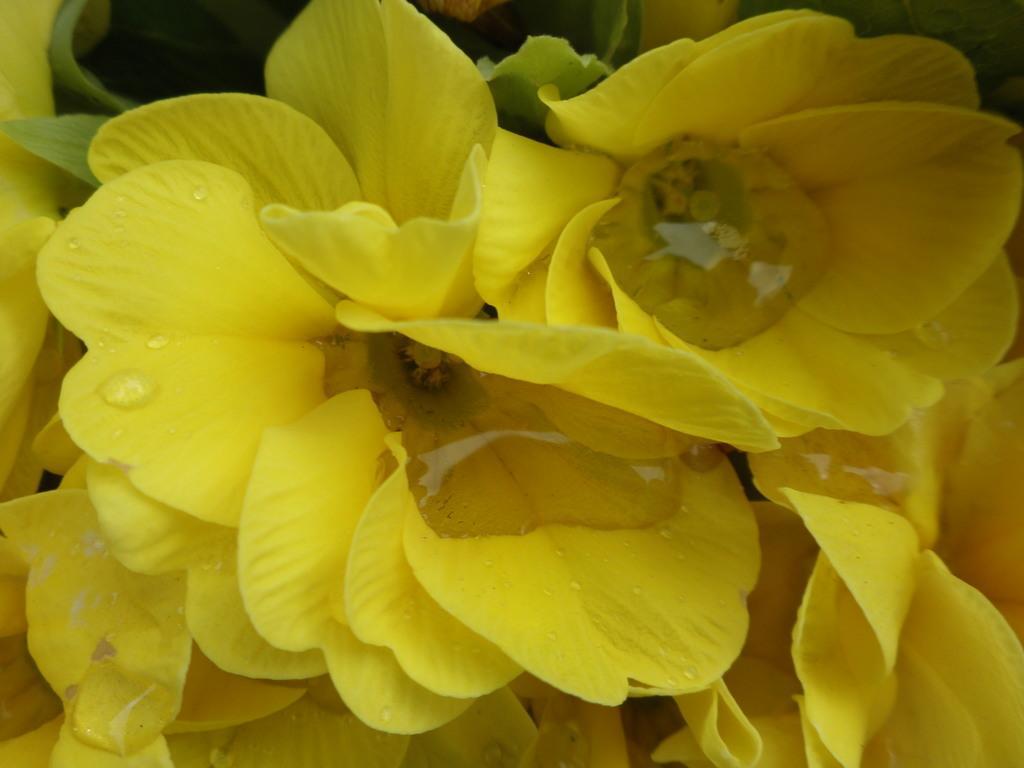Can you describe this image briefly? In this picture there are yellow color flowers and there are water droplets on the flowers. At the back there are leaves. 